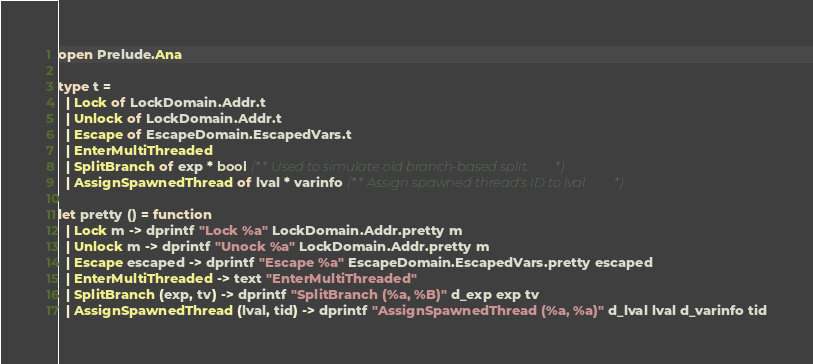<code> <loc_0><loc_0><loc_500><loc_500><_OCaml_>open Prelude.Ana

type t =
  | Lock of LockDomain.Addr.t
  | Unlock of LockDomain.Addr.t
  | Escape of EscapeDomain.EscapedVars.t
  | EnterMultiThreaded
  | SplitBranch of exp * bool (** Used to simulate old branch-based split. *)
  | AssignSpawnedThread of lval * varinfo (** Assign spawned thread's ID to lval. *)

let pretty () = function
  | Lock m -> dprintf "Lock %a" LockDomain.Addr.pretty m
  | Unlock m -> dprintf "Unock %a" LockDomain.Addr.pretty m
  | Escape escaped -> dprintf "Escape %a" EscapeDomain.EscapedVars.pretty escaped
  | EnterMultiThreaded -> text "EnterMultiThreaded"
  | SplitBranch (exp, tv) -> dprintf "SplitBranch (%a, %B)" d_exp exp tv
  | AssignSpawnedThread (lval, tid) -> dprintf "AssignSpawnedThread (%a, %a)" d_lval lval d_varinfo tid
</code> 